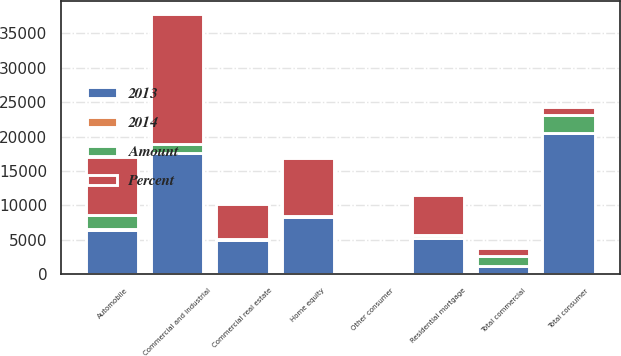<chart> <loc_0><loc_0><loc_500><loc_500><stacked_bar_chart><ecel><fcel>Commercial and industrial<fcel>Commercial real estate<fcel>Total commercial<fcel>Automobile<fcel>Home equity<fcel>Residential mortgage<fcel>Other consumer<fcel>Total consumer<nl><fcel>Percent<fcel>18880<fcel>5084<fcel>1209<fcel>8512<fcel>8452<fcel>5751<fcel>413<fcel>1209<nl><fcel>2013<fcel>17671<fcel>4904<fcel>1209<fcel>6502<fcel>8346<fcel>5331<fcel>385<fcel>20564<nl><fcel>Amount<fcel>1209<fcel>180<fcel>1389<fcel>2010<fcel>106<fcel>420<fcel>28<fcel>2564<nl><fcel>2014<fcel>7<fcel>4<fcel>6<fcel>31<fcel>1<fcel>8<fcel>7<fcel>12<nl></chart> 